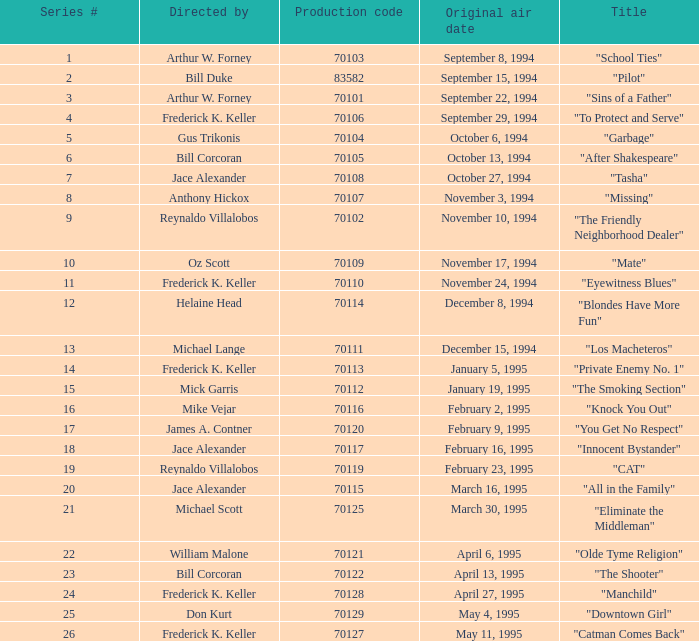What was the lowest production code value in series #10? 70109.0. 